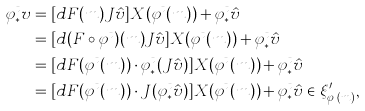<formula> <loc_0><loc_0><loc_500><loc_500>\varphi ^ { t } _ { * } v & = [ d F ( m ) J \hat { v } ] X ( \varphi ^ { t } ( m ) ) + \varphi ^ { t } _ { * } \hat { v } \\ & = [ d ( F \circ \varphi ^ { t } ) ( m ) J \hat { v } ] X ( \varphi ^ { t } ( m ) ) + \varphi ^ { t } _ { * } \hat { v } \\ & = [ d F ( \varphi ^ { t } ( m ) ) \cdot \varphi ^ { t } _ { * } ( J \hat { v } ) ] X ( \varphi ^ { t } ( m ) ) + \varphi ^ { t } _ { * } \hat { v } \\ & = [ d F ( \varphi ^ { t } ( m ) ) \cdot J ( \varphi ^ { t } _ { * } \hat { v } ) ] X ( \varphi ^ { t } ( m ) ) + \varphi ^ { t } _ { * } \hat { v } \in \xi ^ { \prime } _ { \varphi ^ { t } ( m ) } ,</formula> 